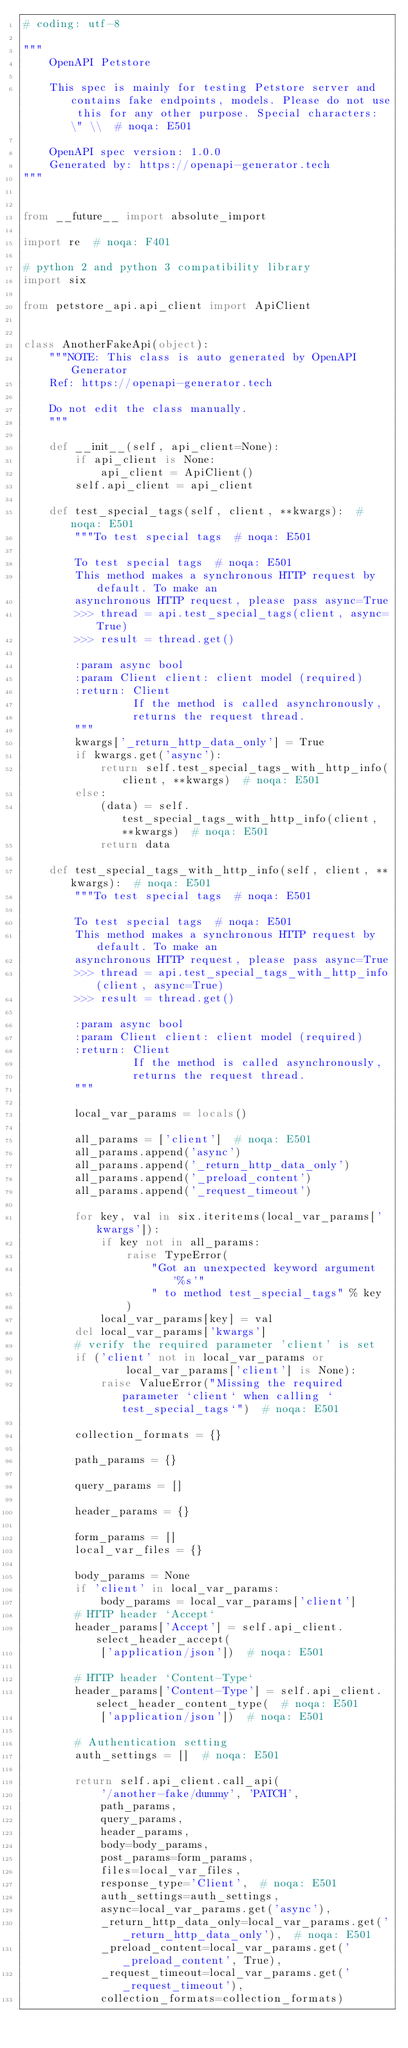<code> <loc_0><loc_0><loc_500><loc_500><_Python_># coding: utf-8

"""
    OpenAPI Petstore

    This spec is mainly for testing Petstore server and contains fake endpoints, models. Please do not use this for any other purpose. Special characters: \" \\  # noqa: E501

    OpenAPI spec version: 1.0.0
    Generated by: https://openapi-generator.tech
"""


from __future__ import absolute_import

import re  # noqa: F401

# python 2 and python 3 compatibility library
import six

from petstore_api.api_client import ApiClient


class AnotherFakeApi(object):
    """NOTE: This class is auto generated by OpenAPI Generator
    Ref: https://openapi-generator.tech

    Do not edit the class manually.
    """

    def __init__(self, api_client=None):
        if api_client is None:
            api_client = ApiClient()
        self.api_client = api_client

    def test_special_tags(self, client, **kwargs):  # noqa: E501
        """To test special tags  # noqa: E501

        To test special tags  # noqa: E501
        This method makes a synchronous HTTP request by default. To make an
        asynchronous HTTP request, please pass async=True
        >>> thread = api.test_special_tags(client, async=True)
        >>> result = thread.get()

        :param async bool
        :param Client client: client model (required)
        :return: Client
                 If the method is called asynchronously,
                 returns the request thread.
        """
        kwargs['_return_http_data_only'] = True
        if kwargs.get('async'):
            return self.test_special_tags_with_http_info(client, **kwargs)  # noqa: E501
        else:
            (data) = self.test_special_tags_with_http_info(client, **kwargs)  # noqa: E501
            return data

    def test_special_tags_with_http_info(self, client, **kwargs):  # noqa: E501
        """To test special tags  # noqa: E501

        To test special tags  # noqa: E501
        This method makes a synchronous HTTP request by default. To make an
        asynchronous HTTP request, please pass async=True
        >>> thread = api.test_special_tags_with_http_info(client, async=True)
        >>> result = thread.get()

        :param async bool
        :param Client client: client model (required)
        :return: Client
                 If the method is called asynchronously,
                 returns the request thread.
        """

        local_var_params = locals()

        all_params = ['client']  # noqa: E501
        all_params.append('async')
        all_params.append('_return_http_data_only')
        all_params.append('_preload_content')
        all_params.append('_request_timeout')

        for key, val in six.iteritems(local_var_params['kwargs']):
            if key not in all_params:
                raise TypeError(
                    "Got an unexpected keyword argument '%s'"
                    " to method test_special_tags" % key
                )
            local_var_params[key] = val
        del local_var_params['kwargs']
        # verify the required parameter 'client' is set
        if ('client' not in local_var_params or
                local_var_params['client'] is None):
            raise ValueError("Missing the required parameter `client` when calling `test_special_tags`")  # noqa: E501

        collection_formats = {}

        path_params = {}

        query_params = []

        header_params = {}

        form_params = []
        local_var_files = {}

        body_params = None
        if 'client' in local_var_params:
            body_params = local_var_params['client']
        # HTTP header `Accept`
        header_params['Accept'] = self.api_client.select_header_accept(
            ['application/json'])  # noqa: E501

        # HTTP header `Content-Type`
        header_params['Content-Type'] = self.api_client.select_header_content_type(  # noqa: E501
            ['application/json'])  # noqa: E501

        # Authentication setting
        auth_settings = []  # noqa: E501

        return self.api_client.call_api(
            '/another-fake/dummy', 'PATCH',
            path_params,
            query_params,
            header_params,
            body=body_params,
            post_params=form_params,
            files=local_var_files,
            response_type='Client',  # noqa: E501
            auth_settings=auth_settings,
            async=local_var_params.get('async'),
            _return_http_data_only=local_var_params.get('_return_http_data_only'),  # noqa: E501
            _preload_content=local_var_params.get('_preload_content', True),
            _request_timeout=local_var_params.get('_request_timeout'),
            collection_formats=collection_formats)
</code> 